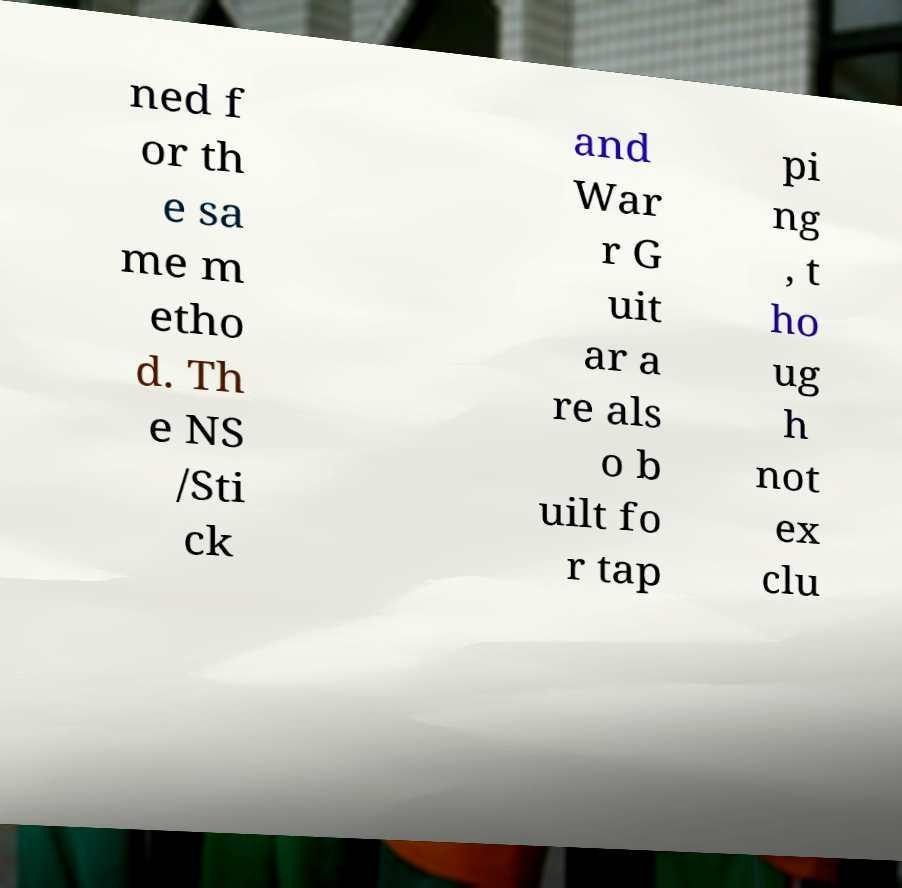I need the written content from this picture converted into text. Can you do that? ned f or th e sa me m etho d. Th e NS /Sti ck and War r G uit ar a re als o b uilt fo r tap pi ng , t ho ug h not ex clu 